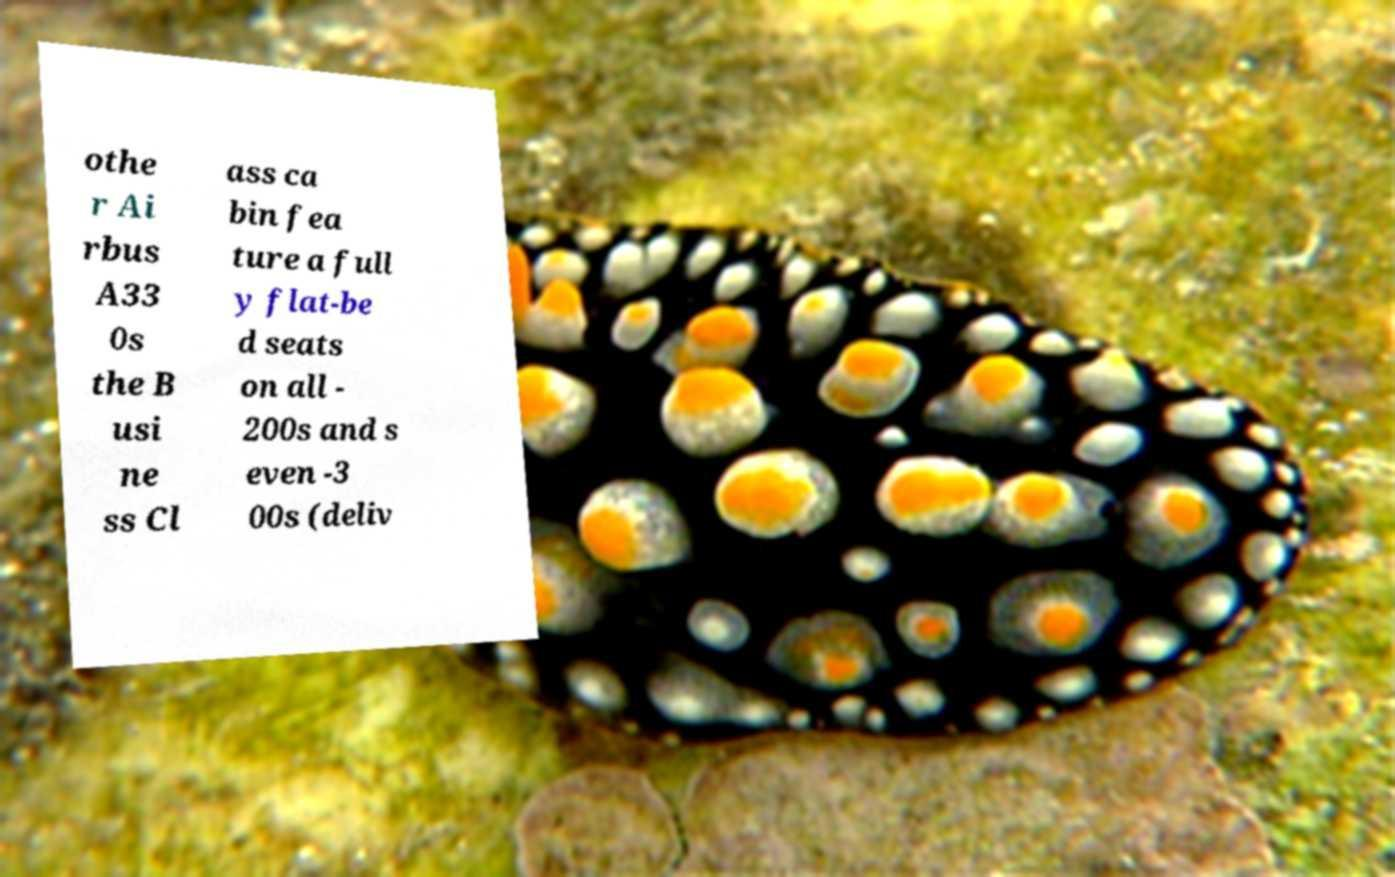Could you extract and type out the text from this image? othe r Ai rbus A33 0s the B usi ne ss Cl ass ca bin fea ture a full y flat-be d seats on all - 200s and s even -3 00s (deliv 